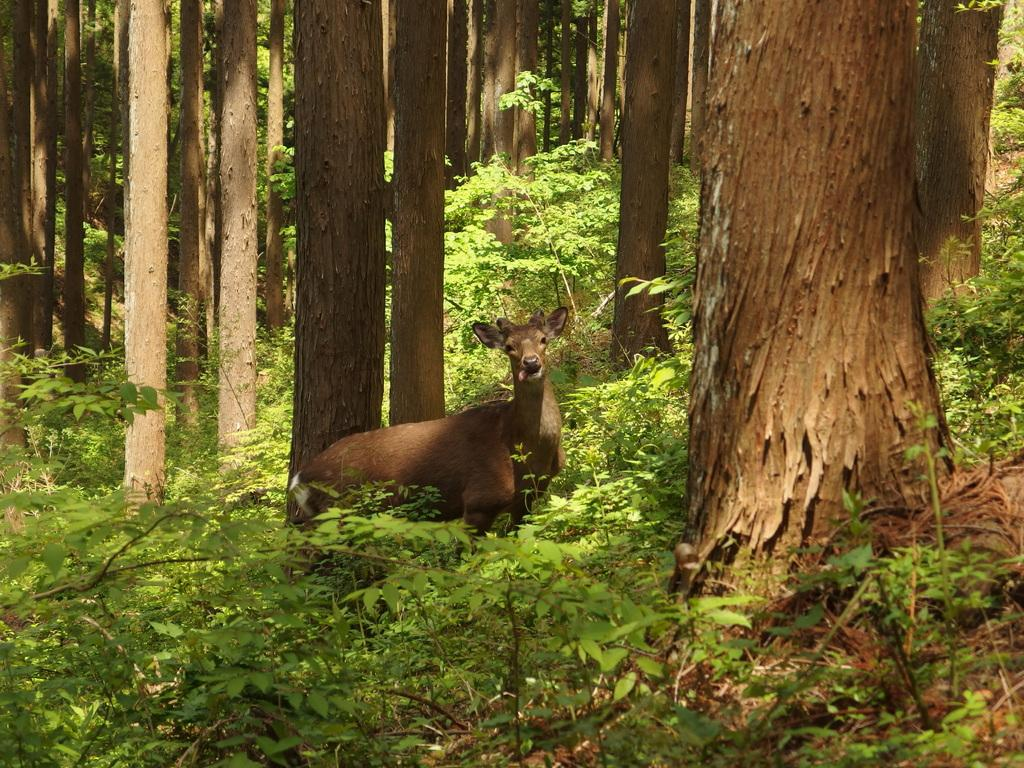What is covering the ground in the image? There are many plants on the ground in the image. Can you describe the animal visible among the plants? Unfortunately, the facts provided do not give enough information to describe the animal. What else can be seen in the image besides plants and an animal? There are tree trunks in the image. What type of cloth is draped over the wall in the image? There is no wall or cloth present in the image; it features many plants and an animal among them. 